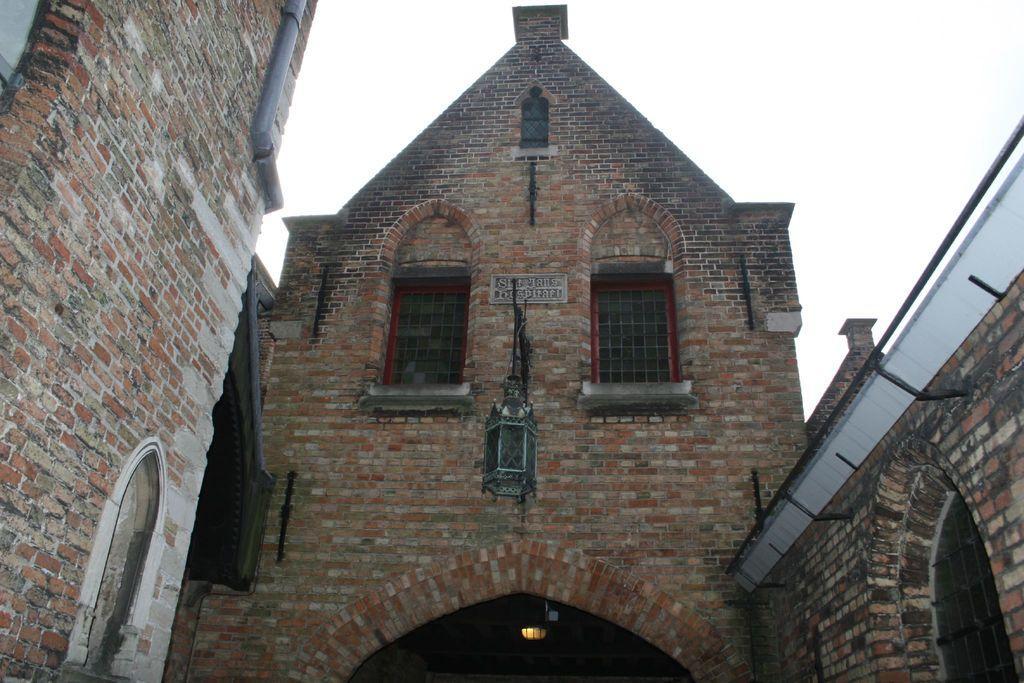How would you summarize this image in a sentence or two? In this image, we can see brick walls, glass windows, rods, pipe and light. Here we can see an object. Background there is the sky. 